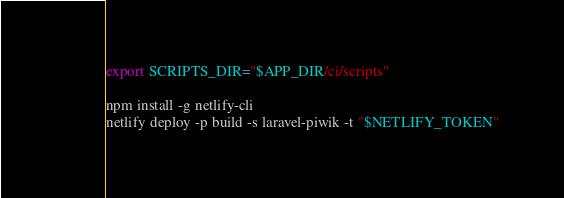<code> <loc_0><loc_0><loc_500><loc_500><_Bash_>export SCRIPTS_DIR="$APP_DIR/ci/scripts"

npm install -g netlify-cli
netlify deploy -p build -s laravel-piwik -t "$NETLIFY_TOKEN"
</code> 